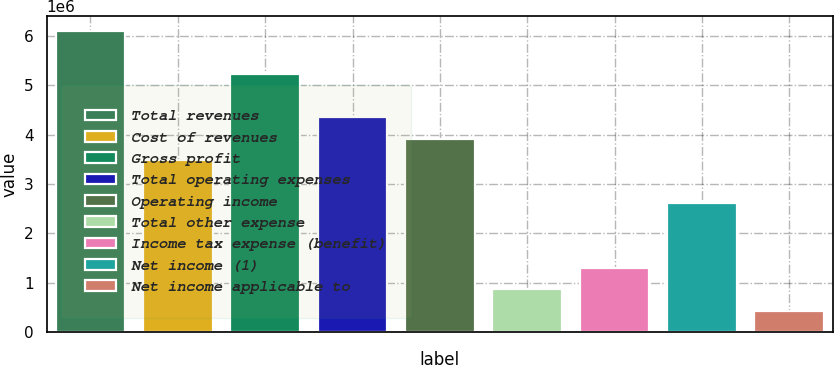<chart> <loc_0><loc_0><loc_500><loc_500><bar_chart><fcel>Total revenues<fcel>Cost of revenues<fcel>Gross profit<fcel>Total operating expenses<fcel>Operating income<fcel>Total other expense<fcel>Income tax expense (benefit)<fcel>Net income (1)<fcel>Net income applicable to<nl><fcel>6.09785e+06<fcel>3.48449e+06<fcel>5.22673e+06<fcel>4.35561e+06<fcel>3.92005e+06<fcel>871139<fcel>1.3067e+06<fcel>2.61337e+06<fcel>435580<nl></chart> 